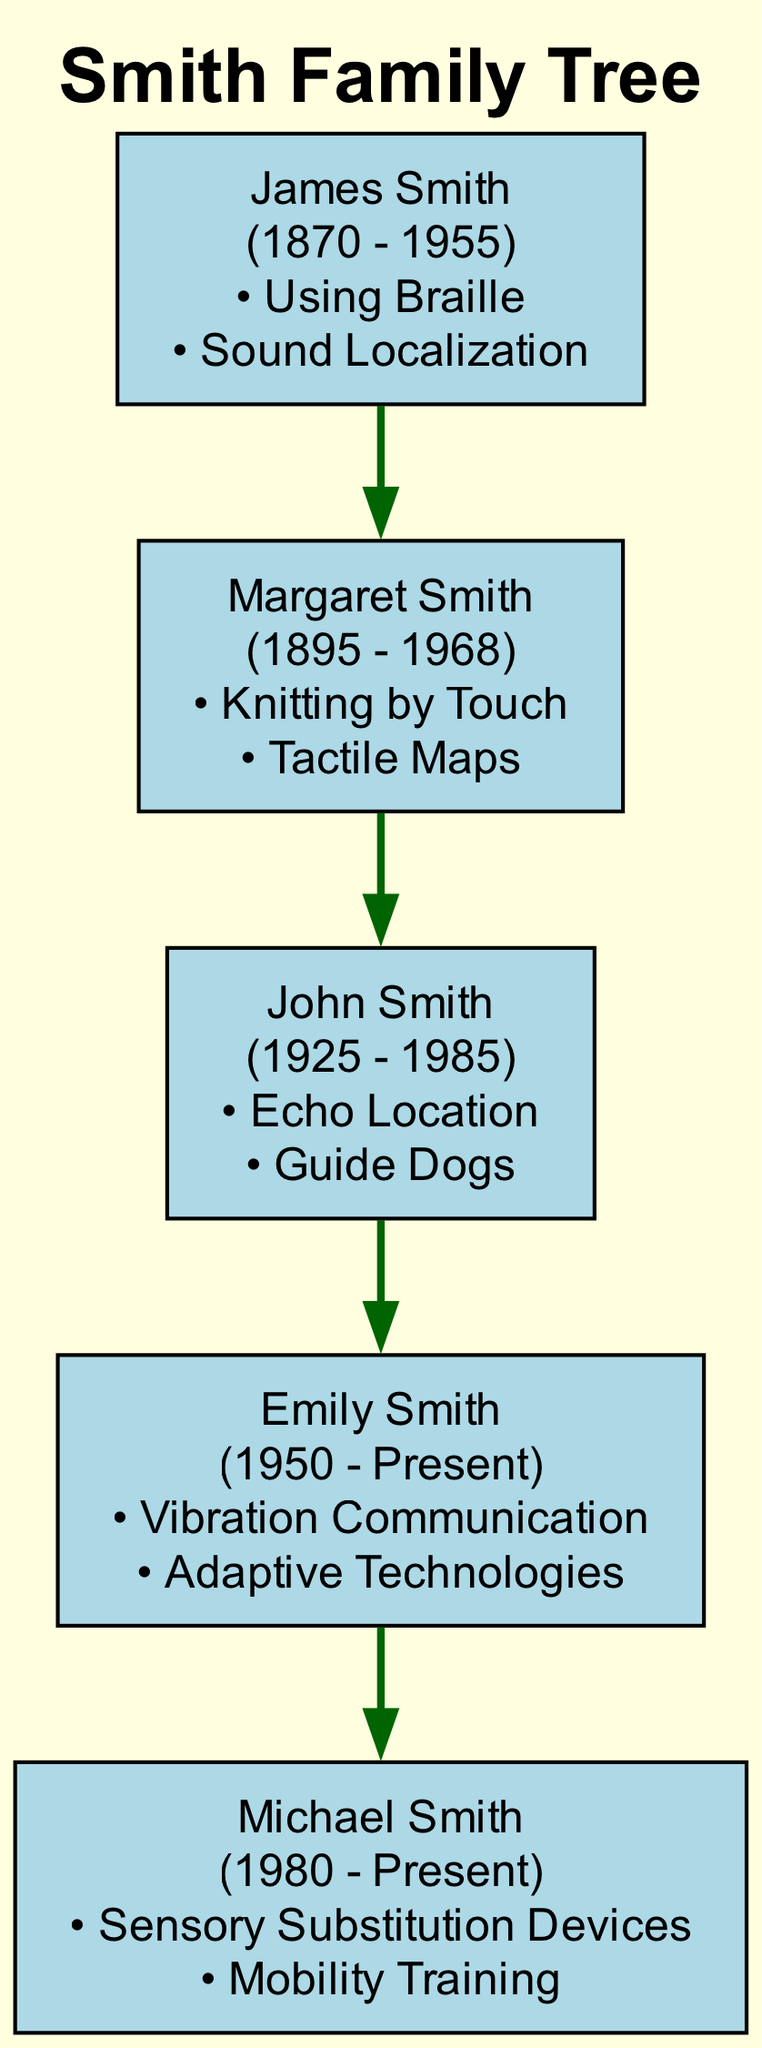What is the birth year of James Smith? The diagram shows that James Smith was born in 1870. This information is directly visible next to his name in the diagram.
Answer: 1870 Who used guide dogs as an adaptive strategy? The diagram states that John Smith adopted guide dogs to enhance mobility and independence. This specific technique is included in his section, indicating its use by him.
Answer: John Smith How many adaptive strategies did Margaret Smith use? By examining the section for Margaret Smith, we can see there are two adaptive strategies listed beneath her name: "Knitting by Touch" and "Tactile Maps." Counting these gives us the total of two.
Answer: 2 Who is the parent of Emily Smith? The diagram shows that John Smith is linked directly to Emily Smith, which indicates that John is her parent as per the family tree structure.
Answer: John Smith What technique did Michael Smith use for sensory substitution? Michael Smith's section lists "Sensory Substitution Devices" as one of his adaptive strategies, specifically addressing the method he uses to enhance sensory perception.
Answer: Sensory Substitution Devices Which member used Braille? The diagram includes a technique used by James Smith, which is "Using Braille." This information is captured in his section, confirming his use of this adaptive strategy.
Answer: James Smith What is the death year of Margaret Smith? The diagram indicates that Margaret Smith died in 1968, which is clearly stated beside her name. This provides the requested information directly from the visual representation.
Answer: 1968 Which family member focused on vibration communication for mobility? In the section for Emily Smith, it is stated that she uses "Vibration Communication" as one of her main adaptive strategies for optimizing touch-based sensory perception.
Answer: Emily Smith How many total members are in the Smith family tree? By counting the members listed in the diagram, we see there are a total of five individuals: James, Margaret, John, Emily, and Michael. Thus, the total is derived from this count.
Answer: 5 